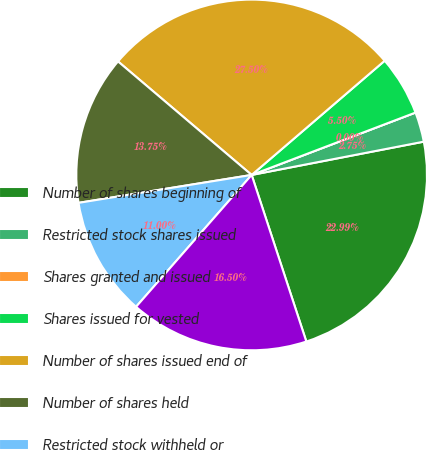<chart> <loc_0><loc_0><loc_500><loc_500><pie_chart><fcel>Number of shares beginning of<fcel>Restricted stock shares issued<fcel>Shares granted and issued<fcel>Shares issued for vested<fcel>Number of shares issued end of<fcel>Number of shares held<fcel>Restricted stock withheld or<fcel>Number of shares held end of<nl><fcel>22.99%<fcel>2.75%<fcel>0.0%<fcel>5.5%<fcel>27.5%<fcel>13.75%<fcel>11.0%<fcel>16.5%<nl></chart> 